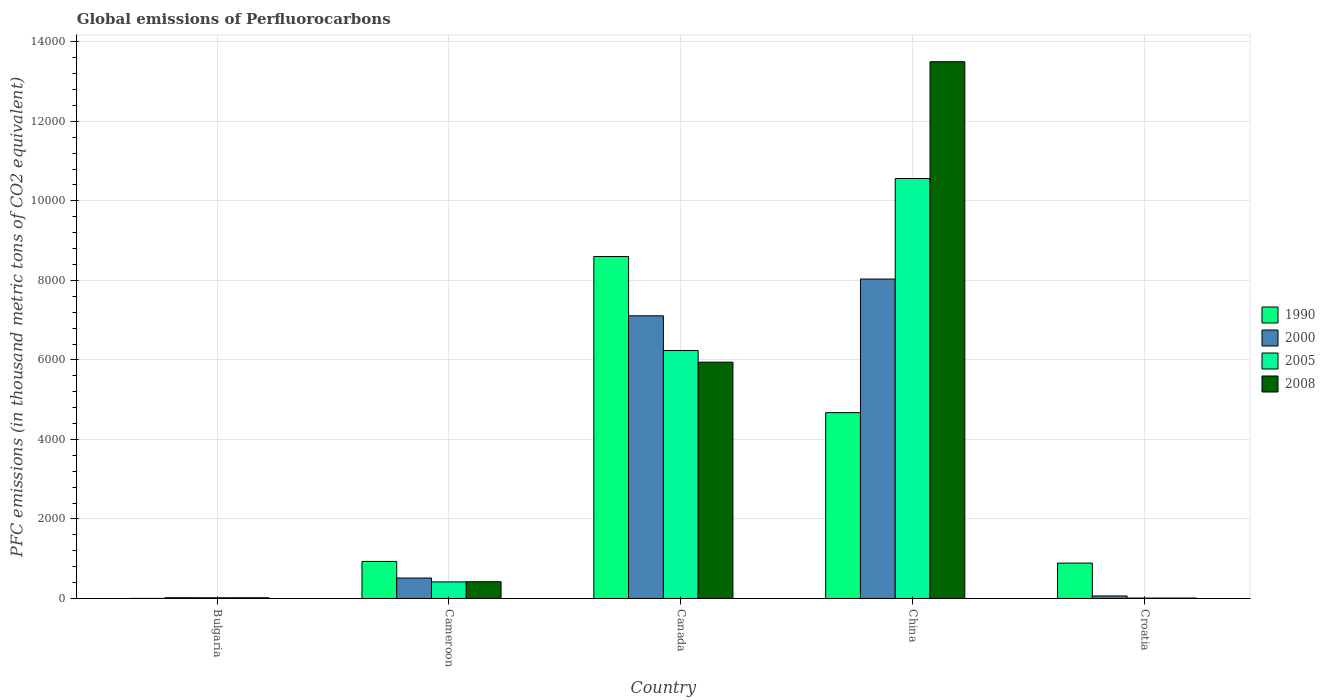How many different coloured bars are there?
Your response must be concise. 4. Are the number of bars per tick equal to the number of legend labels?
Offer a very short reply. Yes. How many bars are there on the 3rd tick from the left?
Provide a succinct answer. 4. What is the label of the 5th group of bars from the left?
Make the answer very short. Croatia. In how many cases, is the number of bars for a given country not equal to the number of legend labels?
Offer a very short reply. 0. What is the global emissions of Perfluorocarbons in 2008 in China?
Provide a short and direct response. 1.35e+04. Across all countries, what is the maximum global emissions of Perfluorocarbons in 2000?
Offer a very short reply. 8034.4. In which country was the global emissions of Perfluorocarbons in 2000 maximum?
Your response must be concise. China. In which country was the global emissions of Perfluorocarbons in 2000 minimum?
Ensure brevity in your answer.  Bulgaria. What is the total global emissions of Perfluorocarbons in 2000 in the graph?
Your answer should be compact. 1.57e+04. What is the difference between the global emissions of Perfluorocarbons in 1990 in Cameroon and that in Canada?
Offer a terse response. -7668. What is the difference between the global emissions of Perfluorocarbons in 1990 in Croatia and the global emissions of Perfluorocarbons in 2000 in Canada?
Provide a succinct answer. -6219.5. What is the average global emissions of Perfluorocarbons in 2000 per country?
Your answer should be compact. 3148.22. What is the difference between the global emissions of Perfluorocarbons of/in 2000 and global emissions of Perfluorocarbons of/in 2008 in China?
Ensure brevity in your answer.  -5466.2. In how many countries, is the global emissions of Perfluorocarbons in 2008 greater than 2800 thousand metric tons?
Your answer should be very brief. 2. What is the ratio of the global emissions of Perfluorocarbons in 2008 in Bulgaria to that in Canada?
Ensure brevity in your answer.  0. Is the global emissions of Perfluorocarbons in 2000 in Bulgaria less than that in Cameroon?
Offer a very short reply. Yes. Is the difference between the global emissions of Perfluorocarbons in 2000 in Canada and China greater than the difference between the global emissions of Perfluorocarbons in 2008 in Canada and China?
Ensure brevity in your answer.  Yes. What is the difference between the highest and the second highest global emissions of Perfluorocarbons in 2008?
Your response must be concise. 1.31e+04. What is the difference between the highest and the lowest global emissions of Perfluorocarbons in 2000?
Offer a very short reply. 8015.3. In how many countries, is the global emissions of Perfluorocarbons in 2005 greater than the average global emissions of Perfluorocarbons in 2005 taken over all countries?
Offer a very short reply. 2. Is the sum of the global emissions of Perfluorocarbons in 2008 in Bulgaria and Canada greater than the maximum global emissions of Perfluorocarbons in 1990 across all countries?
Your answer should be compact. No. What does the 2nd bar from the left in China represents?
Make the answer very short. 2000. Is it the case that in every country, the sum of the global emissions of Perfluorocarbons in 2008 and global emissions of Perfluorocarbons in 2005 is greater than the global emissions of Perfluorocarbons in 1990?
Your answer should be very brief. No. Are all the bars in the graph horizontal?
Give a very brief answer. No. Are the values on the major ticks of Y-axis written in scientific E-notation?
Offer a terse response. No. How are the legend labels stacked?
Provide a short and direct response. Vertical. What is the title of the graph?
Your response must be concise. Global emissions of Perfluorocarbons. Does "2006" appear as one of the legend labels in the graph?
Keep it short and to the point. No. What is the label or title of the Y-axis?
Offer a very short reply. PFC emissions (in thousand metric tons of CO2 equivalent). What is the PFC emissions (in thousand metric tons of CO2 equivalent) in 2008 in Bulgaria?
Provide a short and direct response. 18.2. What is the PFC emissions (in thousand metric tons of CO2 equivalent) in 1990 in Cameroon?
Provide a short and direct response. 932.3. What is the PFC emissions (in thousand metric tons of CO2 equivalent) in 2000 in Cameroon?
Offer a very short reply. 514.7. What is the PFC emissions (in thousand metric tons of CO2 equivalent) in 2005 in Cameroon?
Your response must be concise. 417.5. What is the PFC emissions (in thousand metric tons of CO2 equivalent) of 2008 in Cameroon?
Your response must be concise. 422.1. What is the PFC emissions (in thousand metric tons of CO2 equivalent) of 1990 in Canada?
Offer a very short reply. 8600.3. What is the PFC emissions (in thousand metric tons of CO2 equivalent) in 2000 in Canada?
Your response must be concise. 7109.9. What is the PFC emissions (in thousand metric tons of CO2 equivalent) of 2005 in Canada?
Your answer should be very brief. 6238. What is the PFC emissions (in thousand metric tons of CO2 equivalent) in 2008 in Canada?
Provide a succinct answer. 5943.7. What is the PFC emissions (in thousand metric tons of CO2 equivalent) in 1990 in China?
Ensure brevity in your answer.  4674.5. What is the PFC emissions (in thousand metric tons of CO2 equivalent) of 2000 in China?
Your response must be concise. 8034.4. What is the PFC emissions (in thousand metric tons of CO2 equivalent) in 2005 in China?
Your response must be concise. 1.06e+04. What is the PFC emissions (in thousand metric tons of CO2 equivalent) of 2008 in China?
Provide a succinct answer. 1.35e+04. What is the PFC emissions (in thousand metric tons of CO2 equivalent) of 1990 in Croatia?
Offer a very short reply. 890.4. What is the PFC emissions (in thousand metric tons of CO2 equivalent) in 2005 in Croatia?
Provide a succinct answer. 10.9. What is the PFC emissions (in thousand metric tons of CO2 equivalent) in 2008 in Croatia?
Make the answer very short. 11. Across all countries, what is the maximum PFC emissions (in thousand metric tons of CO2 equivalent) in 1990?
Offer a terse response. 8600.3. Across all countries, what is the maximum PFC emissions (in thousand metric tons of CO2 equivalent) in 2000?
Provide a short and direct response. 8034.4. Across all countries, what is the maximum PFC emissions (in thousand metric tons of CO2 equivalent) in 2005?
Give a very brief answer. 1.06e+04. Across all countries, what is the maximum PFC emissions (in thousand metric tons of CO2 equivalent) in 2008?
Make the answer very short. 1.35e+04. Across all countries, what is the minimum PFC emissions (in thousand metric tons of CO2 equivalent) of 1990?
Your response must be concise. 2.2. Across all countries, what is the minimum PFC emissions (in thousand metric tons of CO2 equivalent) of 2000?
Provide a short and direct response. 19.1. Across all countries, what is the minimum PFC emissions (in thousand metric tons of CO2 equivalent) in 2008?
Give a very brief answer. 11. What is the total PFC emissions (in thousand metric tons of CO2 equivalent) of 1990 in the graph?
Give a very brief answer. 1.51e+04. What is the total PFC emissions (in thousand metric tons of CO2 equivalent) of 2000 in the graph?
Your answer should be compact. 1.57e+04. What is the total PFC emissions (in thousand metric tons of CO2 equivalent) in 2005 in the graph?
Provide a short and direct response. 1.72e+04. What is the total PFC emissions (in thousand metric tons of CO2 equivalent) in 2008 in the graph?
Your answer should be compact. 1.99e+04. What is the difference between the PFC emissions (in thousand metric tons of CO2 equivalent) in 1990 in Bulgaria and that in Cameroon?
Offer a very short reply. -930.1. What is the difference between the PFC emissions (in thousand metric tons of CO2 equivalent) in 2000 in Bulgaria and that in Cameroon?
Offer a terse response. -495.6. What is the difference between the PFC emissions (in thousand metric tons of CO2 equivalent) of 2005 in Bulgaria and that in Cameroon?
Keep it short and to the point. -399. What is the difference between the PFC emissions (in thousand metric tons of CO2 equivalent) in 2008 in Bulgaria and that in Cameroon?
Offer a very short reply. -403.9. What is the difference between the PFC emissions (in thousand metric tons of CO2 equivalent) of 1990 in Bulgaria and that in Canada?
Provide a short and direct response. -8598.1. What is the difference between the PFC emissions (in thousand metric tons of CO2 equivalent) in 2000 in Bulgaria and that in Canada?
Your answer should be very brief. -7090.8. What is the difference between the PFC emissions (in thousand metric tons of CO2 equivalent) of 2005 in Bulgaria and that in Canada?
Your answer should be compact. -6219.5. What is the difference between the PFC emissions (in thousand metric tons of CO2 equivalent) of 2008 in Bulgaria and that in Canada?
Your response must be concise. -5925.5. What is the difference between the PFC emissions (in thousand metric tons of CO2 equivalent) in 1990 in Bulgaria and that in China?
Keep it short and to the point. -4672.3. What is the difference between the PFC emissions (in thousand metric tons of CO2 equivalent) of 2000 in Bulgaria and that in China?
Ensure brevity in your answer.  -8015.3. What is the difference between the PFC emissions (in thousand metric tons of CO2 equivalent) of 2005 in Bulgaria and that in China?
Make the answer very short. -1.05e+04. What is the difference between the PFC emissions (in thousand metric tons of CO2 equivalent) in 2008 in Bulgaria and that in China?
Provide a succinct answer. -1.35e+04. What is the difference between the PFC emissions (in thousand metric tons of CO2 equivalent) in 1990 in Bulgaria and that in Croatia?
Your answer should be compact. -888.2. What is the difference between the PFC emissions (in thousand metric tons of CO2 equivalent) in 2000 in Bulgaria and that in Croatia?
Give a very brief answer. -43.9. What is the difference between the PFC emissions (in thousand metric tons of CO2 equivalent) of 2005 in Bulgaria and that in Croatia?
Provide a short and direct response. 7.6. What is the difference between the PFC emissions (in thousand metric tons of CO2 equivalent) in 2008 in Bulgaria and that in Croatia?
Give a very brief answer. 7.2. What is the difference between the PFC emissions (in thousand metric tons of CO2 equivalent) in 1990 in Cameroon and that in Canada?
Provide a succinct answer. -7668. What is the difference between the PFC emissions (in thousand metric tons of CO2 equivalent) of 2000 in Cameroon and that in Canada?
Make the answer very short. -6595.2. What is the difference between the PFC emissions (in thousand metric tons of CO2 equivalent) in 2005 in Cameroon and that in Canada?
Make the answer very short. -5820.5. What is the difference between the PFC emissions (in thousand metric tons of CO2 equivalent) of 2008 in Cameroon and that in Canada?
Make the answer very short. -5521.6. What is the difference between the PFC emissions (in thousand metric tons of CO2 equivalent) of 1990 in Cameroon and that in China?
Provide a succinct answer. -3742.2. What is the difference between the PFC emissions (in thousand metric tons of CO2 equivalent) in 2000 in Cameroon and that in China?
Make the answer very short. -7519.7. What is the difference between the PFC emissions (in thousand metric tons of CO2 equivalent) in 2005 in Cameroon and that in China?
Ensure brevity in your answer.  -1.01e+04. What is the difference between the PFC emissions (in thousand metric tons of CO2 equivalent) of 2008 in Cameroon and that in China?
Your response must be concise. -1.31e+04. What is the difference between the PFC emissions (in thousand metric tons of CO2 equivalent) of 1990 in Cameroon and that in Croatia?
Offer a very short reply. 41.9. What is the difference between the PFC emissions (in thousand metric tons of CO2 equivalent) in 2000 in Cameroon and that in Croatia?
Offer a terse response. 451.7. What is the difference between the PFC emissions (in thousand metric tons of CO2 equivalent) of 2005 in Cameroon and that in Croatia?
Make the answer very short. 406.6. What is the difference between the PFC emissions (in thousand metric tons of CO2 equivalent) of 2008 in Cameroon and that in Croatia?
Make the answer very short. 411.1. What is the difference between the PFC emissions (in thousand metric tons of CO2 equivalent) of 1990 in Canada and that in China?
Offer a very short reply. 3925.8. What is the difference between the PFC emissions (in thousand metric tons of CO2 equivalent) in 2000 in Canada and that in China?
Offer a terse response. -924.5. What is the difference between the PFC emissions (in thousand metric tons of CO2 equivalent) in 2005 in Canada and that in China?
Ensure brevity in your answer.  -4324.8. What is the difference between the PFC emissions (in thousand metric tons of CO2 equivalent) in 2008 in Canada and that in China?
Make the answer very short. -7556.9. What is the difference between the PFC emissions (in thousand metric tons of CO2 equivalent) of 1990 in Canada and that in Croatia?
Your response must be concise. 7709.9. What is the difference between the PFC emissions (in thousand metric tons of CO2 equivalent) of 2000 in Canada and that in Croatia?
Ensure brevity in your answer.  7046.9. What is the difference between the PFC emissions (in thousand metric tons of CO2 equivalent) in 2005 in Canada and that in Croatia?
Provide a short and direct response. 6227.1. What is the difference between the PFC emissions (in thousand metric tons of CO2 equivalent) in 2008 in Canada and that in Croatia?
Your response must be concise. 5932.7. What is the difference between the PFC emissions (in thousand metric tons of CO2 equivalent) of 1990 in China and that in Croatia?
Keep it short and to the point. 3784.1. What is the difference between the PFC emissions (in thousand metric tons of CO2 equivalent) of 2000 in China and that in Croatia?
Ensure brevity in your answer.  7971.4. What is the difference between the PFC emissions (in thousand metric tons of CO2 equivalent) in 2005 in China and that in Croatia?
Your response must be concise. 1.06e+04. What is the difference between the PFC emissions (in thousand metric tons of CO2 equivalent) in 2008 in China and that in Croatia?
Offer a terse response. 1.35e+04. What is the difference between the PFC emissions (in thousand metric tons of CO2 equivalent) in 1990 in Bulgaria and the PFC emissions (in thousand metric tons of CO2 equivalent) in 2000 in Cameroon?
Your answer should be very brief. -512.5. What is the difference between the PFC emissions (in thousand metric tons of CO2 equivalent) of 1990 in Bulgaria and the PFC emissions (in thousand metric tons of CO2 equivalent) of 2005 in Cameroon?
Provide a succinct answer. -415.3. What is the difference between the PFC emissions (in thousand metric tons of CO2 equivalent) in 1990 in Bulgaria and the PFC emissions (in thousand metric tons of CO2 equivalent) in 2008 in Cameroon?
Provide a short and direct response. -419.9. What is the difference between the PFC emissions (in thousand metric tons of CO2 equivalent) of 2000 in Bulgaria and the PFC emissions (in thousand metric tons of CO2 equivalent) of 2005 in Cameroon?
Give a very brief answer. -398.4. What is the difference between the PFC emissions (in thousand metric tons of CO2 equivalent) of 2000 in Bulgaria and the PFC emissions (in thousand metric tons of CO2 equivalent) of 2008 in Cameroon?
Your response must be concise. -403. What is the difference between the PFC emissions (in thousand metric tons of CO2 equivalent) in 2005 in Bulgaria and the PFC emissions (in thousand metric tons of CO2 equivalent) in 2008 in Cameroon?
Offer a very short reply. -403.6. What is the difference between the PFC emissions (in thousand metric tons of CO2 equivalent) of 1990 in Bulgaria and the PFC emissions (in thousand metric tons of CO2 equivalent) of 2000 in Canada?
Your answer should be very brief. -7107.7. What is the difference between the PFC emissions (in thousand metric tons of CO2 equivalent) in 1990 in Bulgaria and the PFC emissions (in thousand metric tons of CO2 equivalent) in 2005 in Canada?
Give a very brief answer. -6235.8. What is the difference between the PFC emissions (in thousand metric tons of CO2 equivalent) in 1990 in Bulgaria and the PFC emissions (in thousand metric tons of CO2 equivalent) in 2008 in Canada?
Offer a terse response. -5941.5. What is the difference between the PFC emissions (in thousand metric tons of CO2 equivalent) in 2000 in Bulgaria and the PFC emissions (in thousand metric tons of CO2 equivalent) in 2005 in Canada?
Give a very brief answer. -6218.9. What is the difference between the PFC emissions (in thousand metric tons of CO2 equivalent) in 2000 in Bulgaria and the PFC emissions (in thousand metric tons of CO2 equivalent) in 2008 in Canada?
Ensure brevity in your answer.  -5924.6. What is the difference between the PFC emissions (in thousand metric tons of CO2 equivalent) in 2005 in Bulgaria and the PFC emissions (in thousand metric tons of CO2 equivalent) in 2008 in Canada?
Give a very brief answer. -5925.2. What is the difference between the PFC emissions (in thousand metric tons of CO2 equivalent) in 1990 in Bulgaria and the PFC emissions (in thousand metric tons of CO2 equivalent) in 2000 in China?
Your answer should be very brief. -8032.2. What is the difference between the PFC emissions (in thousand metric tons of CO2 equivalent) in 1990 in Bulgaria and the PFC emissions (in thousand metric tons of CO2 equivalent) in 2005 in China?
Offer a terse response. -1.06e+04. What is the difference between the PFC emissions (in thousand metric tons of CO2 equivalent) in 1990 in Bulgaria and the PFC emissions (in thousand metric tons of CO2 equivalent) in 2008 in China?
Your answer should be very brief. -1.35e+04. What is the difference between the PFC emissions (in thousand metric tons of CO2 equivalent) in 2000 in Bulgaria and the PFC emissions (in thousand metric tons of CO2 equivalent) in 2005 in China?
Give a very brief answer. -1.05e+04. What is the difference between the PFC emissions (in thousand metric tons of CO2 equivalent) of 2000 in Bulgaria and the PFC emissions (in thousand metric tons of CO2 equivalent) of 2008 in China?
Give a very brief answer. -1.35e+04. What is the difference between the PFC emissions (in thousand metric tons of CO2 equivalent) in 2005 in Bulgaria and the PFC emissions (in thousand metric tons of CO2 equivalent) in 2008 in China?
Give a very brief answer. -1.35e+04. What is the difference between the PFC emissions (in thousand metric tons of CO2 equivalent) in 1990 in Bulgaria and the PFC emissions (in thousand metric tons of CO2 equivalent) in 2000 in Croatia?
Provide a succinct answer. -60.8. What is the difference between the PFC emissions (in thousand metric tons of CO2 equivalent) of 1990 in Bulgaria and the PFC emissions (in thousand metric tons of CO2 equivalent) of 2005 in Croatia?
Ensure brevity in your answer.  -8.7. What is the difference between the PFC emissions (in thousand metric tons of CO2 equivalent) in 1990 in Bulgaria and the PFC emissions (in thousand metric tons of CO2 equivalent) in 2008 in Croatia?
Give a very brief answer. -8.8. What is the difference between the PFC emissions (in thousand metric tons of CO2 equivalent) of 2000 in Bulgaria and the PFC emissions (in thousand metric tons of CO2 equivalent) of 2005 in Croatia?
Provide a succinct answer. 8.2. What is the difference between the PFC emissions (in thousand metric tons of CO2 equivalent) in 2000 in Bulgaria and the PFC emissions (in thousand metric tons of CO2 equivalent) in 2008 in Croatia?
Ensure brevity in your answer.  8.1. What is the difference between the PFC emissions (in thousand metric tons of CO2 equivalent) in 1990 in Cameroon and the PFC emissions (in thousand metric tons of CO2 equivalent) in 2000 in Canada?
Ensure brevity in your answer.  -6177.6. What is the difference between the PFC emissions (in thousand metric tons of CO2 equivalent) in 1990 in Cameroon and the PFC emissions (in thousand metric tons of CO2 equivalent) in 2005 in Canada?
Your response must be concise. -5305.7. What is the difference between the PFC emissions (in thousand metric tons of CO2 equivalent) of 1990 in Cameroon and the PFC emissions (in thousand metric tons of CO2 equivalent) of 2008 in Canada?
Provide a short and direct response. -5011.4. What is the difference between the PFC emissions (in thousand metric tons of CO2 equivalent) of 2000 in Cameroon and the PFC emissions (in thousand metric tons of CO2 equivalent) of 2005 in Canada?
Give a very brief answer. -5723.3. What is the difference between the PFC emissions (in thousand metric tons of CO2 equivalent) in 2000 in Cameroon and the PFC emissions (in thousand metric tons of CO2 equivalent) in 2008 in Canada?
Give a very brief answer. -5429. What is the difference between the PFC emissions (in thousand metric tons of CO2 equivalent) of 2005 in Cameroon and the PFC emissions (in thousand metric tons of CO2 equivalent) of 2008 in Canada?
Your answer should be very brief. -5526.2. What is the difference between the PFC emissions (in thousand metric tons of CO2 equivalent) in 1990 in Cameroon and the PFC emissions (in thousand metric tons of CO2 equivalent) in 2000 in China?
Your answer should be compact. -7102.1. What is the difference between the PFC emissions (in thousand metric tons of CO2 equivalent) of 1990 in Cameroon and the PFC emissions (in thousand metric tons of CO2 equivalent) of 2005 in China?
Offer a terse response. -9630.5. What is the difference between the PFC emissions (in thousand metric tons of CO2 equivalent) of 1990 in Cameroon and the PFC emissions (in thousand metric tons of CO2 equivalent) of 2008 in China?
Make the answer very short. -1.26e+04. What is the difference between the PFC emissions (in thousand metric tons of CO2 equivalent) of 2000 in Cameroon and the PFC emissions (in thousand metric tons of CO2 equivalent) of 2005 in China?
Provide a succinct answer. -1.00e+04. What is the difference between the PFC emissions (in thousand metric tons of CO2 equivalent) in 2000 in Cameroon and the PFC emissions (in thousand metric tons of CO2 equivalent) in 2008 in China?
Make the answer very short. -1.30e+04. What is the difference between the PFC emissions (in thousand metric tons of CO2 equivalent) in 2005 in Cameroon and the PFC emissions (in thousand metric tons of CO2 equivalent) in 2008 in China?
Make the answer very short. -1.31e+04. What is the difference between the PFC emissions (in thousand metric tons of CO2 equivalent) of 1990 in Cameroon and the PFC emissions (in thousand metric tons of CO2 equivalent) of 2000 in Croatia?
Give a very brief answer. 869.3. What is the difference between the PFC emissions (in thousand metric tons of CO2 equivalent) of 1990 in Cameroon and the PFC emissions (in thousand metric tons of CO2 equivalent) of 2005 in Croatia?
Keep it short and to the point. 921.4. What is the difference between the PFC emissions (in thousand metric tons of CO2 equivalent) of 1990 in Cameroon and the PFC emissions (in thousand metric tons of CO2 equivalent) of 2008 in Croatia?
Give a very brief answer. 921.3. What is the difference between the PFC emissions (in thousand metric tons of CO2 equivalent) in 2000 in Cameroon and the PFC emissions (in thousand metric tons of CO2 equivalent) in 2005 in Croatia?
Your response must be concise. 503.8. What is the difference between the PFC emissions (in thousand metric tons of CO2 equivalent) of 2000 in Cameroon and the PFC emissions (in thousand metric tons of CO2 equivalent) of 2008 in Croatia?
Provide a succinct answer. 503.7. What is the difference between the PFC emissions (in thousand metric tons of CO2 equivalent) in 2005 in Cameroon and the PFC emissions (in thousand metric tons of CO2 equivalent) in 2008 in Croatia?
Provide a short and direct response. 406.5. What is the difference between the PFC emissions (in thousand metric tons of CO2 equivalent) in 1990 in Canada and the PFC emissions (in thousand metric tons of CO2 equivalent) in 2000 in China?
Your answer should be compact. 565.9. What is the difference between the PFC emissions (in thousand metric tons of CO2 equivalent) of 1990 in Canada and the PFC emissions (in thousand metric tons of CO2 equivalent) of 2005 in China?
Make the answer very short. -1962.5. What is the difference between the PFC emissions (in thousand metric tons of CO2 equivalent) in 1990 in Canada and the PFC emissions (in thousand metric tons of CO2 equivalent) in 2008 in China?
Keep it short and to the point. -4900.3. What is the difference between the PFC emissions (in thousand metric tons of CO2 equivalent) of 2000 in Canada and the PFC emissions (in thousand metric tons of CO2 equivalent) of 2005 in China?
Your response must be concise. -3452.9. What is the difference between the PFC emissions (in thousand metric tons of CO2 equivalent) of 2000 in Canada and the PFC emissions (in thousand metric tons of CO2 equivalent) of 2008 in China?
Offer a terse response. -6390.7. What is the difference between the PFC emissions (in thousand metric tons of CO2 equivalent) in 2005 in Canada and the PFC emissions (in thousand metric tons of CO2 equivalent) in 2008 in China?
Make the answer very short. -7262.6. What is the difference between the PFC emissions (in thousand metric tons of CO2 equivalent) in 1990 in Canada and the PFC emissions (in thousand metric tons of CO2 equivalent) in 2000 in Croatia?
Make the answer very short. 8537.3. What is the difference between the PFC emissions (in thousand metric tons of CO2 equivalent) in 1990 in Canada and the PFC emissions (in thousand metric tons of CO2 equivalent) in 2005 in Croatia?
Give a very brief answer. 8589.4. What is the difference between the PFC emissions (in thousand metric tons of CO2 equivalent) in 1990 in Canada and the PFC emissions (in thousand metric tons of CO2 equivalent) in 2008 in Croatia?
Your answer should be very brief. 8589.3. What is the difference between the PFC emissions (in thousand metric tons of CO2 equivalent) of 2000 in Canada and the PFC emissions (in thousand metric tons of CO2 equivalent) of 2005 in Croatia?
Your response must be concise. 7099. What is the difference between the PFC emissions (in thousand metric tons of CO2 equivalent) in 2000 in Canada and the PFC emissions (in thousand metric tons of CO2 equivalent) in 2008 in Croatia?
Your answer should be very brief. 7098.9. What is the difference between the PFC emissions (in thousand metric tons of CO2 equivalent) in 2005 in Canada and the PFC emissions (in thousand metric tons of CO2 equivalent) in 2008 in Croatia?
Ensure brevity in your answer.  6227. What is the difference between the PFC emissions (in thousand metric tons of CO2 equivalent) in 1990 in China and the PFC emissions (in thousand metric tons of CO2 equivalent) in 2000 in Croatia?
Your answer should be very brief. 4611.5. What is the difference between the PFC emissions (in thousand metric tons of CO2 equivalent) in 1990 in China and the PFC emissions (in thousand metric tons of CO2 equivalent) in 2005 in Croatia?
Your response must be concise. 4663.6. What is the difference between the PFC emissions (in thousand metric tons of CO2 equivalent) of 1990 in China and the PFC emissions (in thousand metric tons of CO2 equivalent) of 2008 in Croatia?
Ensure brevity in your answer.  4663.5. What is the difference between the PFC emissions (in thousand metric tons of CO2 equivalent) in 2000 in China and the PFC emissions (in thousand metric tons of CO2 equivalent) in 2005 in Croatia?
Offer a very short reply. 8023.5. What is the difference between the PFC emissions (in thousand metric tons of CO2 equivalent) of 2000 in China and the PFC emissions (in thousand metric tons of CO2 equivalent) of 2008 in Croatia?
Give a very brief answer. 8023.4. What is the difference between the PFC emissions (in thousand metric tons of CO2 equivalent) of 2005 in China and the PFC emissions (in thousand metric tons of CO2 equivalent) of 2008 in Croatia?
Ensure brevity in your answer.  1.06e+04. What is the average PFC emissions (in thousand metric tons of CO2 equivalent) in 1990 per country?
Offer a very short reply. 3019.94. What is the average PFC emissions (in thousand metric tons of CO2 equivalent) in 2000 per country?
Provide a succinct answer. 3148.22. What is the average PFC emissions (in thousand metric tons of CO2 equivalent) of 2005 per country?
Offer a very short reply. 3449.54. What is the average PFC emissions (in thousand metric tons of CO2 equivalent) in 2008 per country?
Provide a succinct answer. 3979.12. What is the difference between the PFC emissions (in thousand metric tons of CO2 equivalent) in 1990 and PFC emissions (in thousand metric tons of CO2 equivalent) in 2000 in Bulgaria?
Keep it short and to the point. -16.9. What is the difference between the PFC emissions (in thousand metric tons of CO2 equivalent) of 1990 and PFC emissions (in thousand metric tons of CO2 equivalent) of 2005 in Bulgaria?
Your response must be concise. -16.3. What is the difference between the PFC emissions (in thousand metric tons of CO2 equivalent) of 1990 and PFC emissions (in thousand metric tons of CO2 equivalent) of 2008 in Bulgaria?
Your response must be concise. -16. What is the difference between the PFC emissions (in thousand metric tons of CO2 equivalent) of 2000 and PFC emissions (in thousand metric tons of CO2 equivalent) of 2005 in Bulgaria?
Your answer should be compact. 0.6. What is the difference between the PFC emissions (in thousand metric tons of CO2 equivalent) in 2000 and PFC emissions (in thousand metric tons of CO2 equivalent) in 2008 in Bulgaria?
Provide a short and direct response. 0.9. What is the difference between the PFC emissions (in thousand metric tons of CO2 equivalent) of 2005 and PFC emissions (in thousand metric tons of CO2 equivalent) of 2008 in Bulgaria?
Your answer should be very brief. 0.3. What is the difference between the PFC emissions (in thousand metric tons of CO2 equivalent) in 1990 and PFC emissions (in thousand metric tons of CO2 equivalent) in 2000 in Cameroon?
Your response must be concise. 417.6. What is the difference between the PFC emissions (in thousand metric tons of CO2 equivalent) in 1990 and PFC emissions (in thousand metric tons of CO2 equivalent) in 2005 in Cameroon?
Make the answer very short. 514.8. What is the difference between the PFC emissions (in thousand metric tons of CO2 equivalent) of 1990 and PFC emissions (in thousand metric tons of CO2 equivalent) of 2008 in Cameroon?
Provide a short and direct response. 510.2. What is the difference between the PFC emissions (in thousand metric tons of CO2 equivalent) of 2000 and PFC emissions (in thousand metric tons of CO2 equivalent) of 2005 in Cameroon?
Your response must be concise. 97.2. What is the difference between the PFC emissions (in thousand metric tons of CO2 equivalent) in 2000 and PFC emissions (in thousand metric tons of CO2 equivalent) in 2008 in Cameroon?
Offer a very short reply. 92.6. What is the difference between the PFC emissions (in thousand metric tons of CO2 equivalent) in 2005 and PFC emissions (in thousand metric tons of CO2 equivalent) in 2008 in Cameroon?
Ensure brevity in your answer.  -4.6. What is the difference between the PFC emissions (in thousand metric tons of CO2 equivalent) of 1990 and PFC emissions (in thousand metric tons of CO2 equivalent) of 2000 in Canada?
Provide a short and direct response. 1490.4. What is the difference between the PFC emissions (in thousand metric tons of CO2 equivalent) of 1990 and PFC emissions (in thousand metric tons of CO2 equivalent) of 2005 in Canada?
Make the answer very short. 2362.3. What is the difference between the PFC emissions (in thousand metric tons of CO2 equivalent) in 1990 and PFC emissions (in thousand metric tons of CO2 equivalent) in 2008 in Canada?
Provide a short and direct response. 2656.6. What is the difference between the PFC emissions (in thousand metric tons of CO2 equivalent) of 2000 and PFC emissions (in thousand metric tons of CO2 equivalent) of 2005 in Canada?
Keep it short and to the point. 871.9. What is the difference between the PFC emissions (in thousand metric tons of CO2 equivalent) of 2000 and PFC emissions (in thousand metric tons of CO2 equivalent) of 2008 in Canada?
Make the answer very short. 1166.2. What is the difference between the PFC emissions (in thousand metric tons of CO2 equivalent) in 2005 and PFC emissions (in thousand metric tons of CO2 equivalent) in 2008 in Canada?
Offer a terse response. 294.3. What is the difference between the PFC emissions (in thousand metric tons of CO2 equivalent) in 1990 and PFC emissions (in thousand metric tons of CO2 equivalent) in 2000 in China?
Provide a short and direct response. -3359.9. What is the difference between the PFC emissions (in thousand metric tons of CO2 equivalent) of 1990 and PFC emissions (in thousand metric tons of CO2 equivalent) of 2005 in China?
Give a very brief answer. -5888.3. What is the difference between the PFC emissions (in thousand metric tons of CO2 equivalent) of 1990 and PFC emissions (in thousand metric tons of CO2 equivalent) of 2008 in China?
Your response must be concise. -8826.1. What is the difference between the PFC emissions (in thousand metric tons of CO2 equivalent) in 2000 and PFC emissions (in thousand metric tons of CO2 equivalent) in 2005 in China?
Your response must be concise. -2528.4. What is the difference between the PFC emissions (in thousand metric tons of CO2 equivalent) in 2000 and PFC emissions (in thousand metric tons of CO2 equivalent) in 2008 in China?
Offer a very short reply. -5466.2. What is the difference between the PFC emissions (in thousand metric tons of CO2 equivalent) of 2005 and PFC emissions (in thousand metric tons of CO2 equivalent) of 2008 in China?
Provide a short and direct response. -2937.8. What is the difference between the PFC emissions (in thousand metric tons of CO2 equivalent) of 1990 and PFC emissions (in thousand metric tons of CO2 equivalent) of 2000 in Croatia?
Your answer should be compact. 827.4. What is the difference between the PFC emissions (in thousand metric tons of CO2 equivalent) of 1990 and PFC emissions (in thousand metric tons of CO2 equivalent) of 2005 in Croatia?
Provide a short and direct response. 879.5. What is the difference between the PFC emissions (in thousand metric tons of CO2 equivalent) of 1990 and PFC emissions (in thousand metric tons of CO2 equivalent) of 2008 in Croatia?
Your answer should be compact. 879.4. What is the difference between the PFC emissions (in thousand metric tons of CO2 equivalent) of 2000 and PFC emissions (in thousand metric tons of CO2 equivalent) of 2005 in Croatia?
Keep it short and to the point. 52.1. What is the difference between the PFC emissions (in thousand metric tons of CO2 equivalent) in 2000 and PFC emissions (in thousand metric tons of CO2 equivalent) in 2008 in Croatia?
Keep it short and to the point. 52. What is the ratio of the PFC emissions (in thousand metric tons of CO2 equivalent) in 1990 in Bulgaria to that in Cameroon?
Your response must be concise. 0. What is the ratio of the PFC emissions (in thousand metric tons of CO2 equivalent) in 2000 in Bulgaria to that in Cameroon?
Make the answer very short. 0.04. What is the ratio of the PFC emissions (in thousand metric tons of CO2 equivalent) of 2005 in Bulgaria to that in Cameroon?
Give a very brief answer. 0.04. What is the ratio of the PFC emissions (in thousand metric tons of CO2 equivalent) in 2008 in Bulgaria to that in Cameroon?
Your answer should be very brief. 0.04. What is the ratio of the PFC emissions (in thousand metric tons of CO2 equivalent) of 1990 in Bulgaria to that in Canada?
Make the answer very short. 0. What is the ratio of the PFC emissions (in thousand metric tons of CO2 equivalent) in 2000 in Bulgaria to that in Canada?
Ensure brevity in your answer.  0. What is the ratio of the PFC emissions (in thousand metric tons of CO2 equivalent) in 2005 in Bulgaria to that in Canada?
Provide a short and direct response. 0. What is the ratio of the PFC emissions (in thousand metric tons of CO2 equivalent) of 2008 in Bulgaria to that in Canada?
Offer a very short reply. 0. What is the ratio of the PFC emissions (in thousand metric tons of CO2 equivalent) of 2000 in Bulgaria to that in China?
Keep it short and to the point. 0. What is the ratio of the PFC emissions (in thousand metric tons of CO2 equivalent) of 2005 in Bulgaria to that in China?
Offer a terse response. 0. What is the ratio of the PFC emissions (in thousand metric tons of CO2 equivalent) in 2008 in Bulgaria to that in China?
Your answer should be very brief. 0. What is the ratio of the PFC emissions (in thousand metric tons of CO2 equivalent) of 1990 in Bulgaria to that in Croatia?
Offer a very short reply. 0. What is the ratio of the PFC emissions (in thousand metric tons of CO2 equivalent) in 2000 in Bulgaria to that in Croatia?
Keep it short and to the point. 0.3. What is the ratio of the PFC emissions (in thousand metric tons of CO2 equivalent) in 2005 in Bulgaria to that in Croatia?
Provide a short and direct response. 1.7. What is the ratio of the PFC emissions (in thousand metric tons of CO2 equivalent) in 2008 in Bulgaria to that in Croatia?
Your response must be concise. 1.65. What is the ratio of the PFC emissions (in thousand metric tons of CO2 equivalent) in 1990 in Cameroon to that in Canada?
Your answer should be very brief. 0.11. What is the ratio of the PFC emissions (in thousand metric tons of CO2 equivalent) of 2000 in Cameroon to that in Canada?
Offer a very short reply. 0.07. What is the ratio of the PFC emissions (in thousand metric tons of CO2 equivalent) of 2005 in Cameroon to that in Canada?
Make the answer very short. 0.07. What is the ratio of the PFC emissions (in thousand metric tons of CO2 equivalent) in 2008 in Cameroon to that in Canada?
Give a very brief answer. 0.07. What is the ratio of the PFC emissions (in thousand metric tons of CO2 equivalent) of 1990 in Cameroon to that in China?
Your answer should be compact. 0.2. What is the ratio of the PFC emissions (in thousand metric tons of CO2 equivalent) of 2000 in Cameroon to that in China?
Make the answer very short. 0.06. What is the ratio of the PFC emissions (in thousand metric tons of CO2 equivalent) in 2005 in Cameroon to that in China?
Keep it short and to the point. 0.04. What is the ratio of the PFC emissions (in thousand metric tons of CO2 equivalent) in 2008 in Cameroon to that in China?
Your answer should be compact. 0.03. What is the ratio of the PFC emissions (in thousand metric tons of CO2 equivalent) in 1990 in Cameroon to that in Croatia?
Your response must be concise. 1.05. What is the ratio of the PFC emissions (in thousand metric tons of CO2 equivalent) in 2000 in Cameroon to that in Croatia?
Your answer should be compact. 8.17. What is the ratio of the PFC emissions (in thousand metric tons of CO2 equivalent) of 2005 in Cameroon to that in Croatia?
Keep it short and to the point. 38.3. What is the ratio of the PFC emissions (in thousand metric tons of CO2 equivalent) of 2008 in Cameroon to that in Croatia?
Your response must be concise. 38.37. What is the ratio of the PFC emissions (in thousand metric tons of CO2 equivalent) of 1990 in Canada to that in China?
Your answer should be very brief. 1.84. What is the ratio of the PFC emissions (in thousand metric tons of CO2 equivalent) in 2000 in Canada to that in China?
Make the answer very short. 0.88. What is the ratio of the PFC emissions (in thousand metric tons of CO2 equivalent) of 2005 in Canada to that in China?
Ensure brevity in your answer.  0.59. What is the ratio of the PFC emissions (in thousand metric tons of CO2 equivalent) of 2008 in Canada to that in China?
Make the answer very short. 0.44. What is the ratio of the PFC emissions (in thousand metric tons of CO2 equivalent) in 1990 in Canada to that in Croatia?
Provide a succinct answer. 9.66. What is the ratio of the PFC emissions (in thousand metric tons of CO2 equivalent) of 2000 in Canada to that in Croatia?
Provide a short and direct response. 112.86. What is the ratio of the PFC emissions (in thousand metric tons of CO2 equivalent) in 2005 in Canada to that in Croatia?
Offer a terse response. 572.29. What is the ratio of the PFC emissions (in thousand metric tons of CO2 equivalent) in 2008 in Canada to that in Croatia?
Provide a short and direct response. 540.34. What is the ratio of the PFC emissions (in thousand metric tons of CO2 equivalent) in 1990 in China to that in Croatia?
Your answer should be very brief. 5.25. What is the ratio of the PFC emissions (in thousand metric tons of CO2 equivalent) of 2000 in China to that in Croatia?
Keep it short and to the point. 127.53. What is the ratio of the PFC emissions (in thousand metric tons of CO2 equivalent) in 2005 in China to that in Croatia?
Your response must be concise. 969.06. What is the ratio of the PFC emissions (in thousand metric tons of CO2 equivalent) in 2008 in China to that in Croatia?
Ensure brevity in your answer.  1227.33. What is the difference between the highest and the second highest PFC emissions (in thousand metric tons of CO2 equivalent) of 1990?
Offer a very short reply. 3925.8. What is the difference between the highest and the second highest PFC emissions (in thousand metric tons of CO2 equivalent) in 2000?
Your answer should be very brief. 924.5. What is the difference between the highest and the second highest PFC emissions (in thousand metric tons of CO2 equivalent) of 2005?
Offer a terse response. 4324.8. What is the difference between the highest and the second highest PFC emissions (in thousand metric tons of CO2 equivalent) of 2008?
Make the answer very short. 7556.9. What is the difference between the highest and the lowest PFC emissions (in thousand metric tons of CO2 equivalent) in 1990?
Offer a terse response. 8598.1. What is the difference between the highest and the lowest PFC emissions (in thousand metric tons of CO2 equivalent) in 2000?
Give a very brief answer. 8015.3. What is the difference between the highest and the lowest PFC emissions (in thousand metric tons of CO2 equivalent) in 2005?
Your response must be concise. 1.06e+04. What is the difference between the highest and the lowest PFC emissions (in thousand metric tons of CO2 equivalent) in 2008?
Your response must be concise. 1.35e+04. 